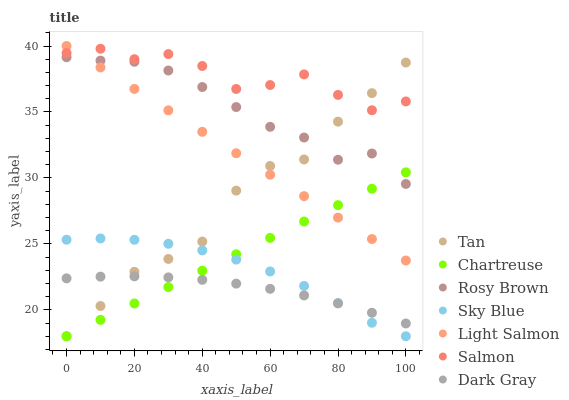Does Dark Gray have the minimum area under the curve?
Answer yes or no. Yes. Does Salmon have the maximum area under the curve?
Answer yes or no. Yes. Does Rosy Brown have the minimum area under the curve?
Answer yes or no. No. Does Rosy Brown have the maximum area under the curve?
Answer yes or no. No. Is Chartreuse the smoothest?
Answer yes or no. Yes. Is Salmon the roughest?
Answer yes or no. Yes. Is Rosy Brown the smoothest?
Answer yes or no. No. Is Rosy Brown the roughest?
Answer yes or no. No. Does Chartreuse have the lowest value?
Answer yes or no. Yes. Does Rosy Brown have the lowest value?
Answer yes or no. No. Does Light Salmon have the highest value?
Answer yes or no. Yes. Does Rosy Brown have the highest value?
Answer yes or no. No. Is Dark Gray less than Salmon?
Answer yes or no. Yes. Is Salmon greater than Chartreuse?
Answer yes or no. Yes. Does Sky Blue intersect Chartreuse?
Answer yes or no. Yes. Is Sky Blue less than Chartreuse?
Answer yes or no. No. Is Sky Blue greater than Chartreuse?
Answer yes or no. No. Does Dark Gray intersect Salmon?
Answer yes or no. No. 